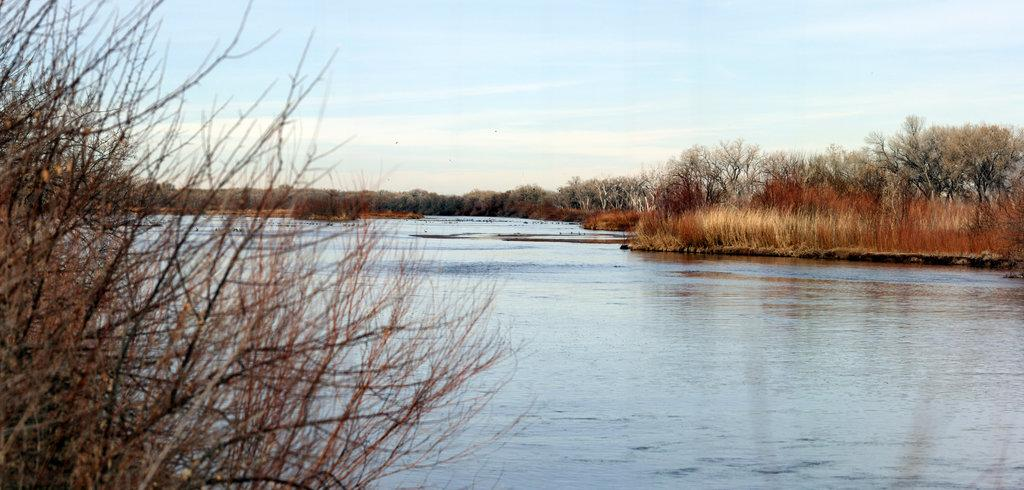What is the main feature in the center of the image? There is a lake in the center of the image. What can be seen in the foreground of the image? There are plants in the foreground of the image. What type of vegetation is visible in the background of the image? There are trees in the background of the image. What is visible at the top of the image? The sky is visible at the top of the image. What type of science experiment is being conducted near the gate in the image? There is no gate or science experiment present in the image. 